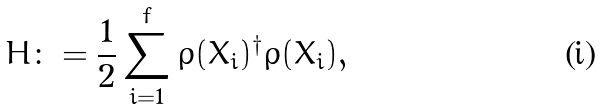<formula> <loc_0><loc_0><loc_500><loc_500>H \colon = \frac { 1 } { 2 } \sum _ { i = 1 } ^ { f } \rho ( X _ { i } ) ^ { \dagger } \rho ( X _ { i } ) ,</formula> 